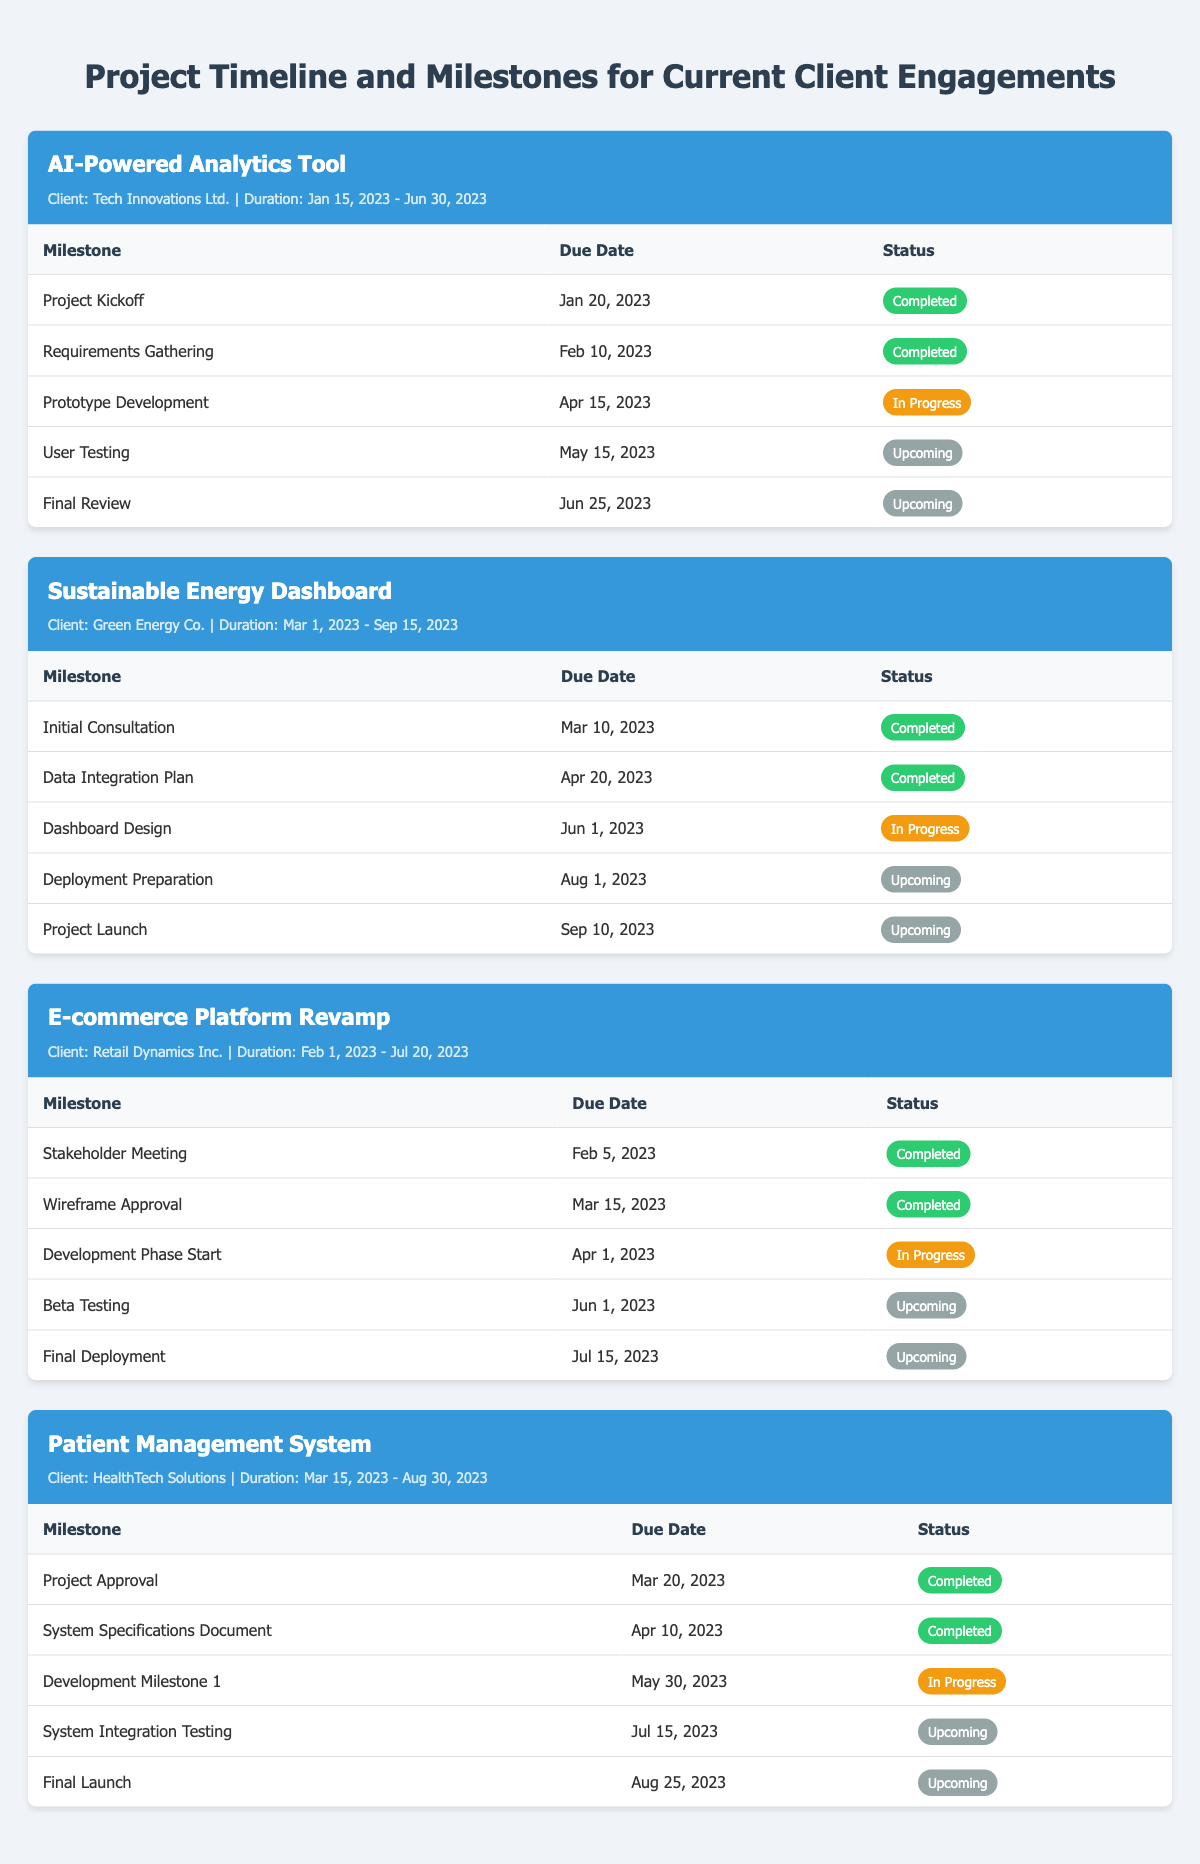What is the status of the 'Prototype Development' milestone for Tech Innovations Ltd.? The 'Prototype Development' milestone is listed with a status of 'In Progress' in the project for Tech Innovations Ltd.
Answer: In Progress When is the 'Final Review' milestone due for the AI-Powered Analytics Tool? The 'Final Review' milestone is due on June 25, 2023, as indicated in the table for the AI-Powered Analytics Tool.
Answer: June 25, 2023 Is the 'Beta Testing' milestone for Retail Dynamics Inc. completed? The 'Beta Testing' milestone has a status of 'Upcoming', thus it is not completed yet.
Answer: No How many milestones have been marked as 'Completed' for Green Energy Co.? There are 2 milestones marked as 'Completed' in the project for Green Energy Co. which are 'Initial Consultation' and 'Data Integration Plan'.
Answer: 2 Which project has its last milestone due the earliest among all listed projects? The 'Final Deployment' milestone for 'E-commerce Platform Revamp' is due on July 15, 2023, which is the earliest final milestone due amongst all projects listed.
Answer: E-commerce Platform Revamp What percentage of milestones are 'Upcoming' for the Patient Management System? Out of 5 milestones, 3 are 'Upcoming'. The percentage is (3/5) * 100 = 60%.
Answer: 60% How many milestones are currently 'In Progress' across all projects? There are 4 milestones marked as 'In Progress' across all projects, specifically in the projects of Tech Innovations Ltd., Green Energy Co., Retail Dynamics Inc., and HealthTech Solutions.
Answer: 4 Which client has the earliest project start date? Tech Innovations Ltd. has the earliest project start date on January 15, 2023, compared to other clients.
Answer: Tech Innovations Ltd Is the status of the 'Dashboard Design' milestone for Green Energy Co. 'Completed'? The status for 'Dashboard Design' is 'In Progress', not 'Completed', hence the answer is false.
Answer: No How many total milestones are planned for the HealthTech Solutions project? The HealthTech Solutions project has a total of 5 milestones planned, as shown in the table.
Answer: 5 